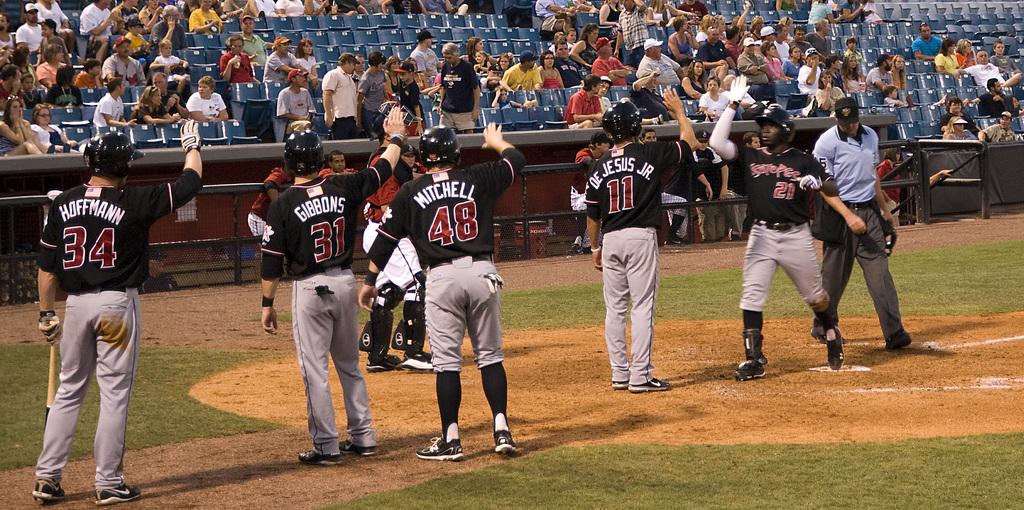Who wears number 48?
Your answer should be compact. Mitchell. 